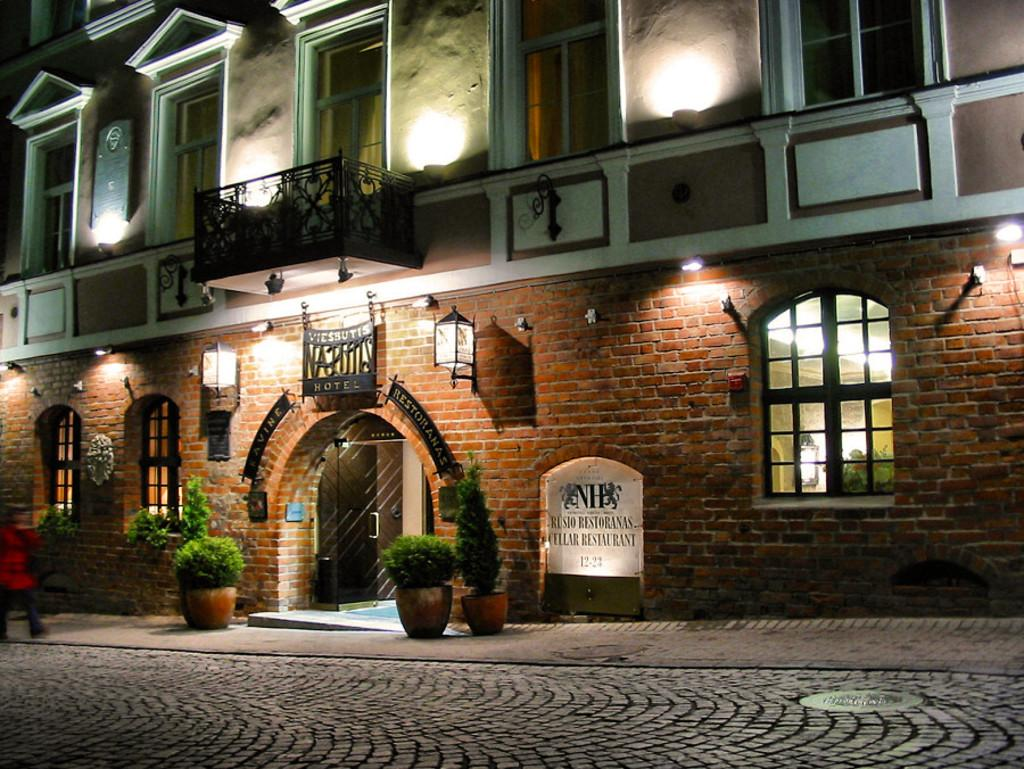<image>
Render a clear and concise summary of the photo. A brick building with Rusio Restoranas Cellar Restaurant on it. 